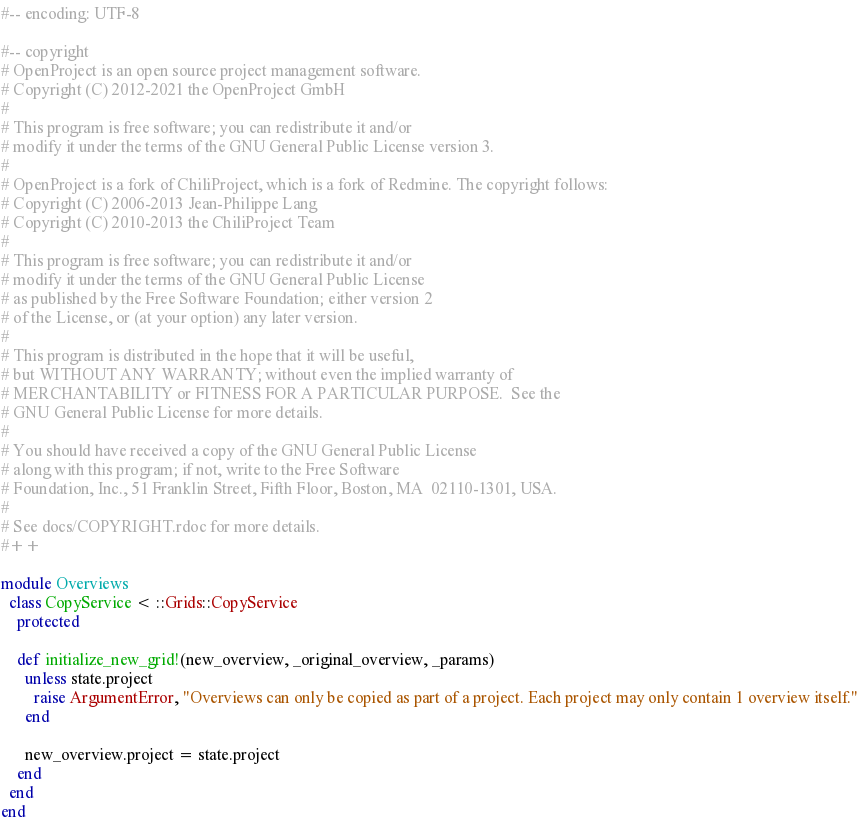Convert code to text. <code><loc_0><loc_0><loc_500><loc_500><_Ruby_>#-- encoding: UTF-8

#-- copyright
# OpenProject is an open source project management software.
# Copyright (C) 2012-2021 the OpenProject GmbH
#
# This program is free software; you can redistribute it and/or
# modify it under the terms of the GNU General Public License version 3.
#
# OpenProject is a fork of ChiliProject, which is a fork of Redmine. The copyright follows:
# Copyright (C) 2006-2013 Jean-Philippe Lang
# Copyright (C) 2010-2013 the ChiliProject Team
#
# This program is free software; you can redistribute it and/or
# modify it under the terms of the GNU General Public License
# as published by the Free Software Foundation; either version 2
# of the License, or (at your option) any later version.
#
# This program is distributed in the hope that it will be useful,
# but WITHOUT ANY WARRANTY; without even the implied warranty of
# MERCHANTABILITY or FITNESS FOR A PARTICULAR PURPOSE.  See the
# GNU General Public License for more details.
#
# You should have received a copy of the GNU General Public License
# along with this program; if not, write to the Free Software
# Foundation, Inc., 51 Franklin Street, Fifth Floor, Boston, MA  02110-1301, USA.
#
# See docs/COPYRIGHT.rdoc for more details.
#++

module Overviews
  class CopyService < ::Grids::CopyService
    protected

    def initialize_new_grid!(new_overview, _original_overview, _params)
      unless state.project
        raise ArgumentError, "Overviews can only be copied as part of a project. Each project may only contain 1 overview itself."
      end

      new_overview.project = state.project
    end
  end
end
</code> 